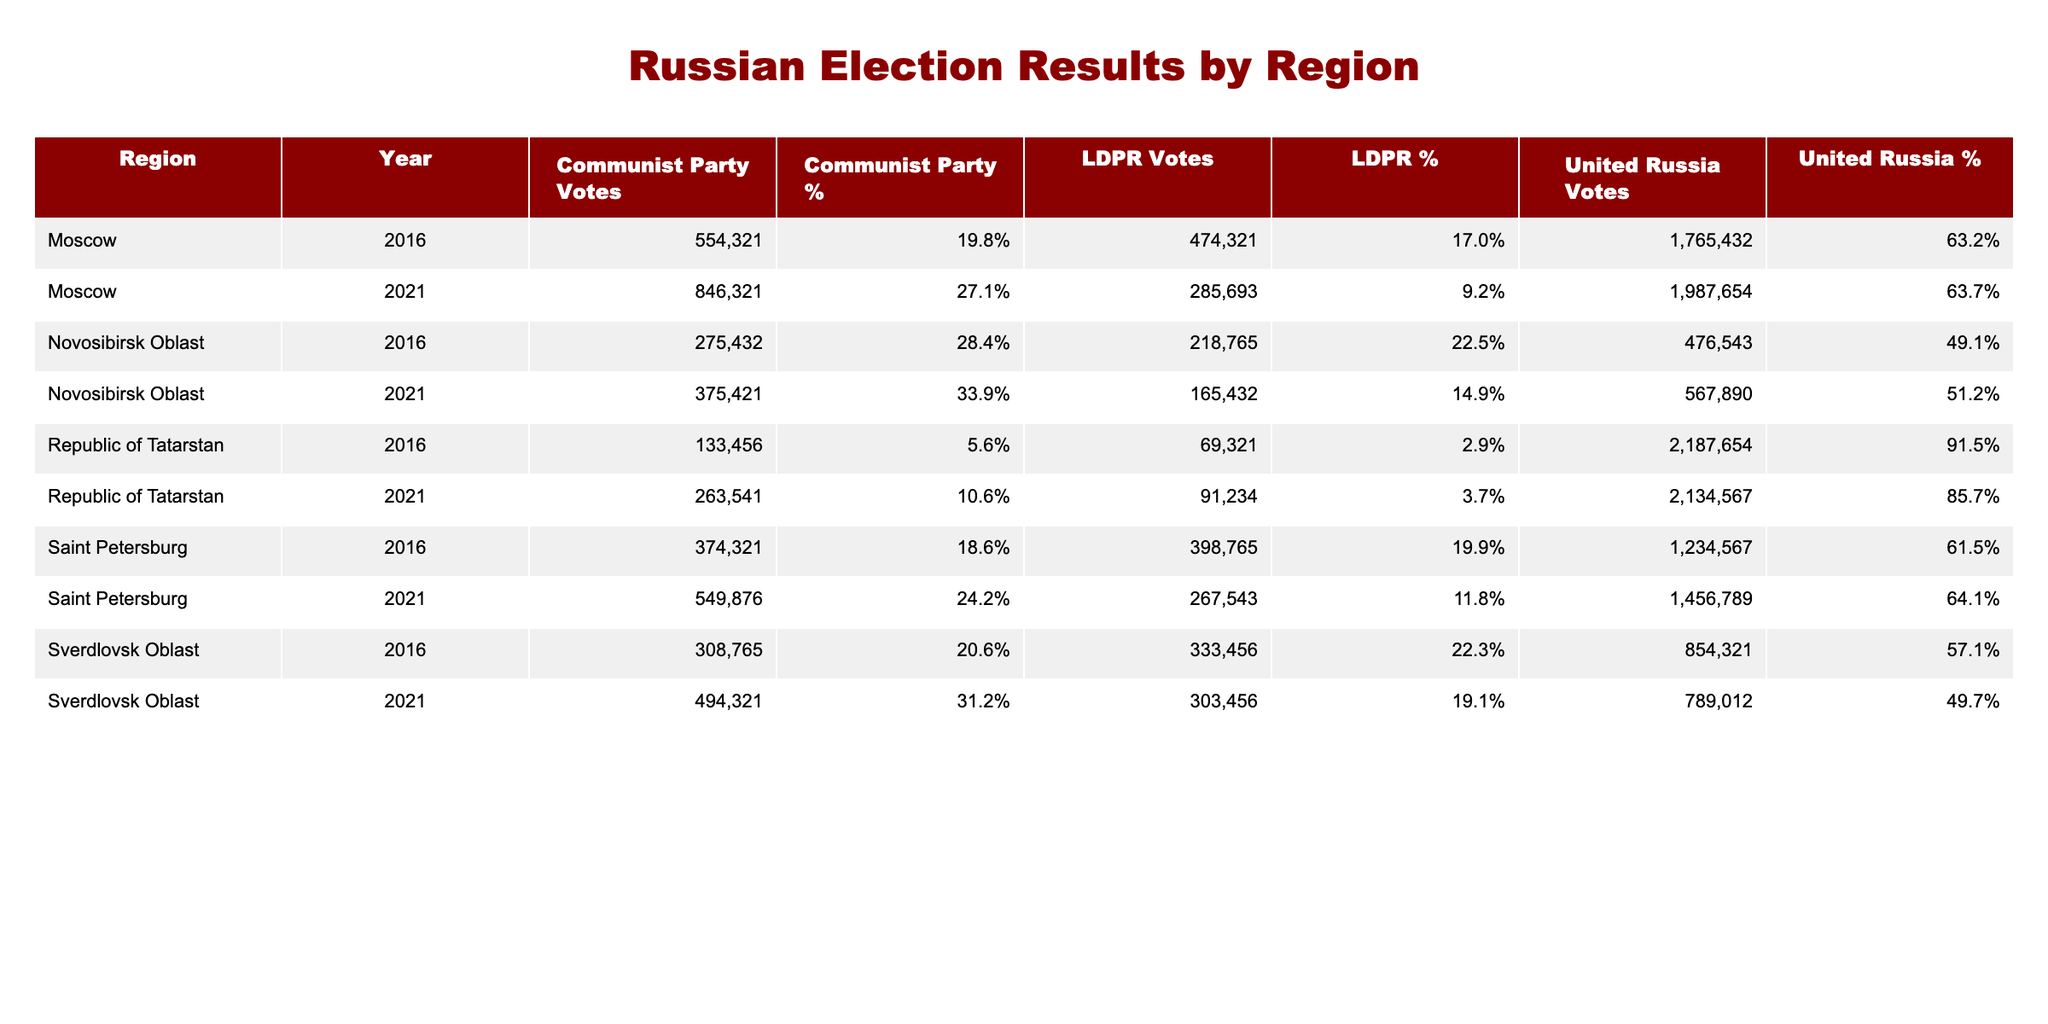What was the voter turnout percentage for United Russia in the Republic of Tatarstan in 2021? According to the table, the voter turnout percentage for United Russia in the Republic of Tatarstan in 2021 is listed directly. Looking at the corresponding entry, it is 79.3%.
Answer: 79.3% Which party received the highest number of votes in Moscow in 2016? By examining the votes for each party in Moscow for the year 2016, we see that United Russia received 1,765,432 votes, which is greater than that of the Communist Party (554,321) and LDPR (474,321). Hence, United Russia received the highest number of votes.
Answer: United Russia What is the average voter turnout for the Communist Party across all regions in 2021? We first need to identify the voter turnout percentage for the Communist Party in each region for 2021: Moscow (23.1%), Saint Petersburg (18.9%), Novosibirsk Oblast (25.6%), Republic of Tatarstan (9.8%), and Sverdlovsk Oblast (22.3%). We then sum these percentages: 23.1 + 18.9 + 25.6 + 9.8 + 22.3 = 99.7%. There are 5 regions, so we compute the average by dividing: 99.7% / 5 = 19.94%. Rounded to one decimal place, the average voter turnout is 19.9%.
Answer: 19.9% Did the voter turnout for United Russia increase from 2016 to 2021 in Saint Petersburg? For United Russia in Saint Petersburg, the voter turnout was 45.2% in 2016 and increased to 50.1% in 2021. Since 50.1% is greater than 45.2%, we can affirm that there was an increase in voter turnout.
Answer: Yes What is the difference in total votes for United Russia between 2021 and 2016 in the Republic of Tatarstan? In 2021, United Russia received 2,134,567 votes, while in 2016 it received 2,187,654 votes. Therefore, we calculate the difference: 2,187,654 - 2,134,567 = 53,087. Thus, the total votes decreased by 53,087 from 2016 to 2021.
Answer: 53,087 